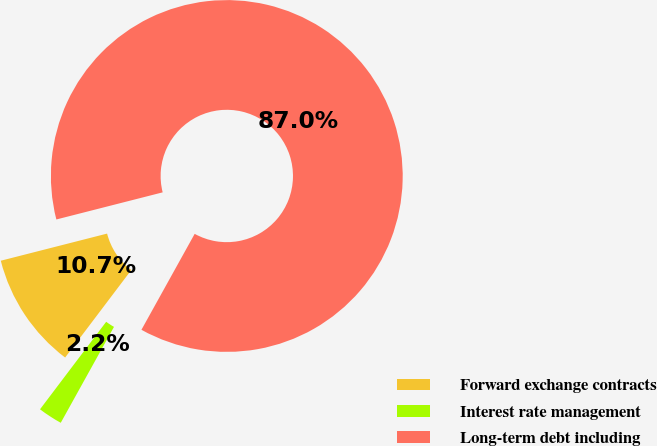Convert chart to OTSL. <chart><loc_0><loc_0><loc_500><loc_500><pie_chart><fcel>Forward exchange contracts<fcel>Interest rate management<fcel>Long-term debt including<nl><fcel>10.72%<fcel>2.24%<fcel>87.04%<nl></chart> 